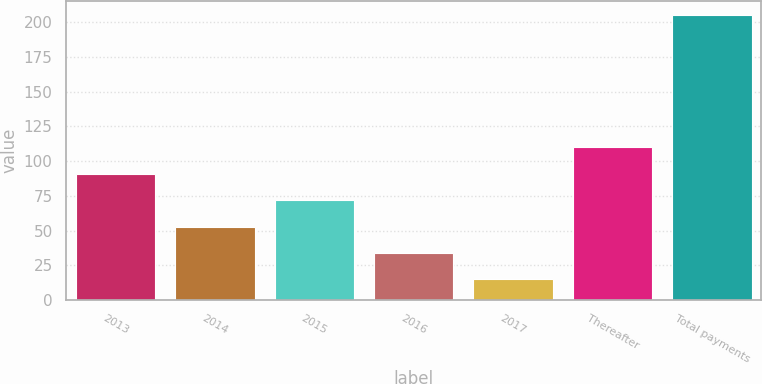Convert chart to OTSL. <chart><loc_0><loc_0><loc_500><loc_500><bar_chart><fcel>2013<fcel>2014<fcel>2015<fcel>2016<fcel>2017<fcel>Thereafter<fcel>Total payments<nl><fcel>91<fcel>53<fcel>72<fcel>34<fcel>15<fcel>110<fcel>205<nl></chart> 